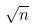<formula> <loc_0><loc_0><loc_500><loc_500>\sqrt { n }</formula> 